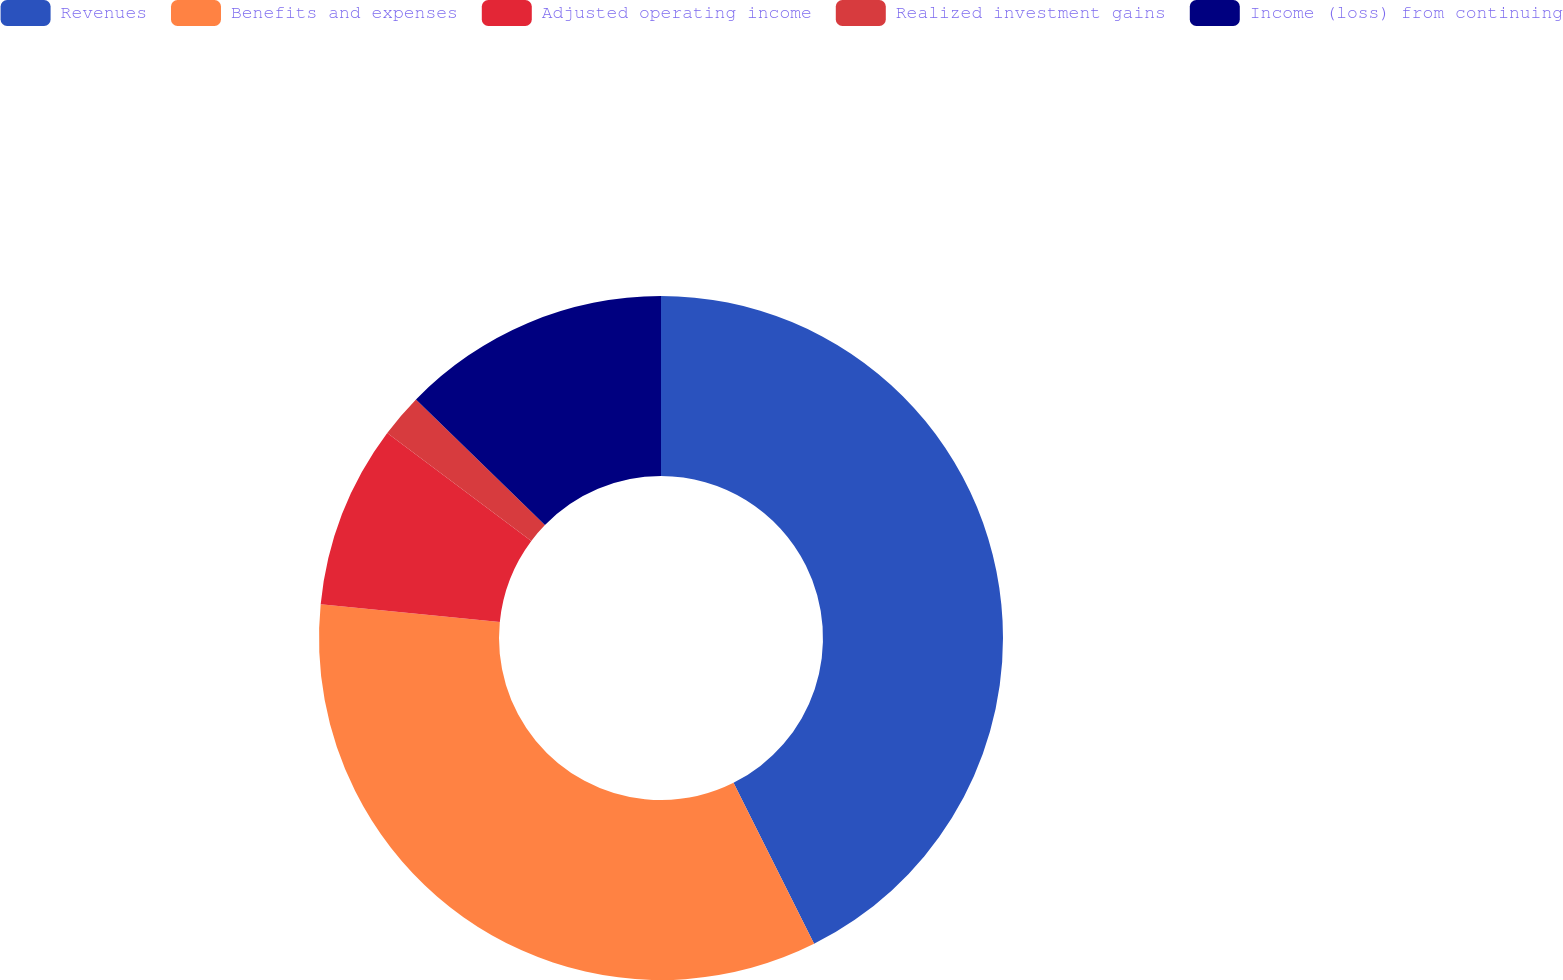<chart> <loc_0><loc_0><loc_500><loc_500><pie_chart><fcel>Revenues<fcel>Benefits and expenses<fcel>Adjusted operating income<fcel>Realized investment gains<fcel>Income (loss) from continuing<nl><fcel>42.61%<fcel>33.96%<fcel>8.65%<fcel>2.06%<fcel>12.71%<nl></chart> 